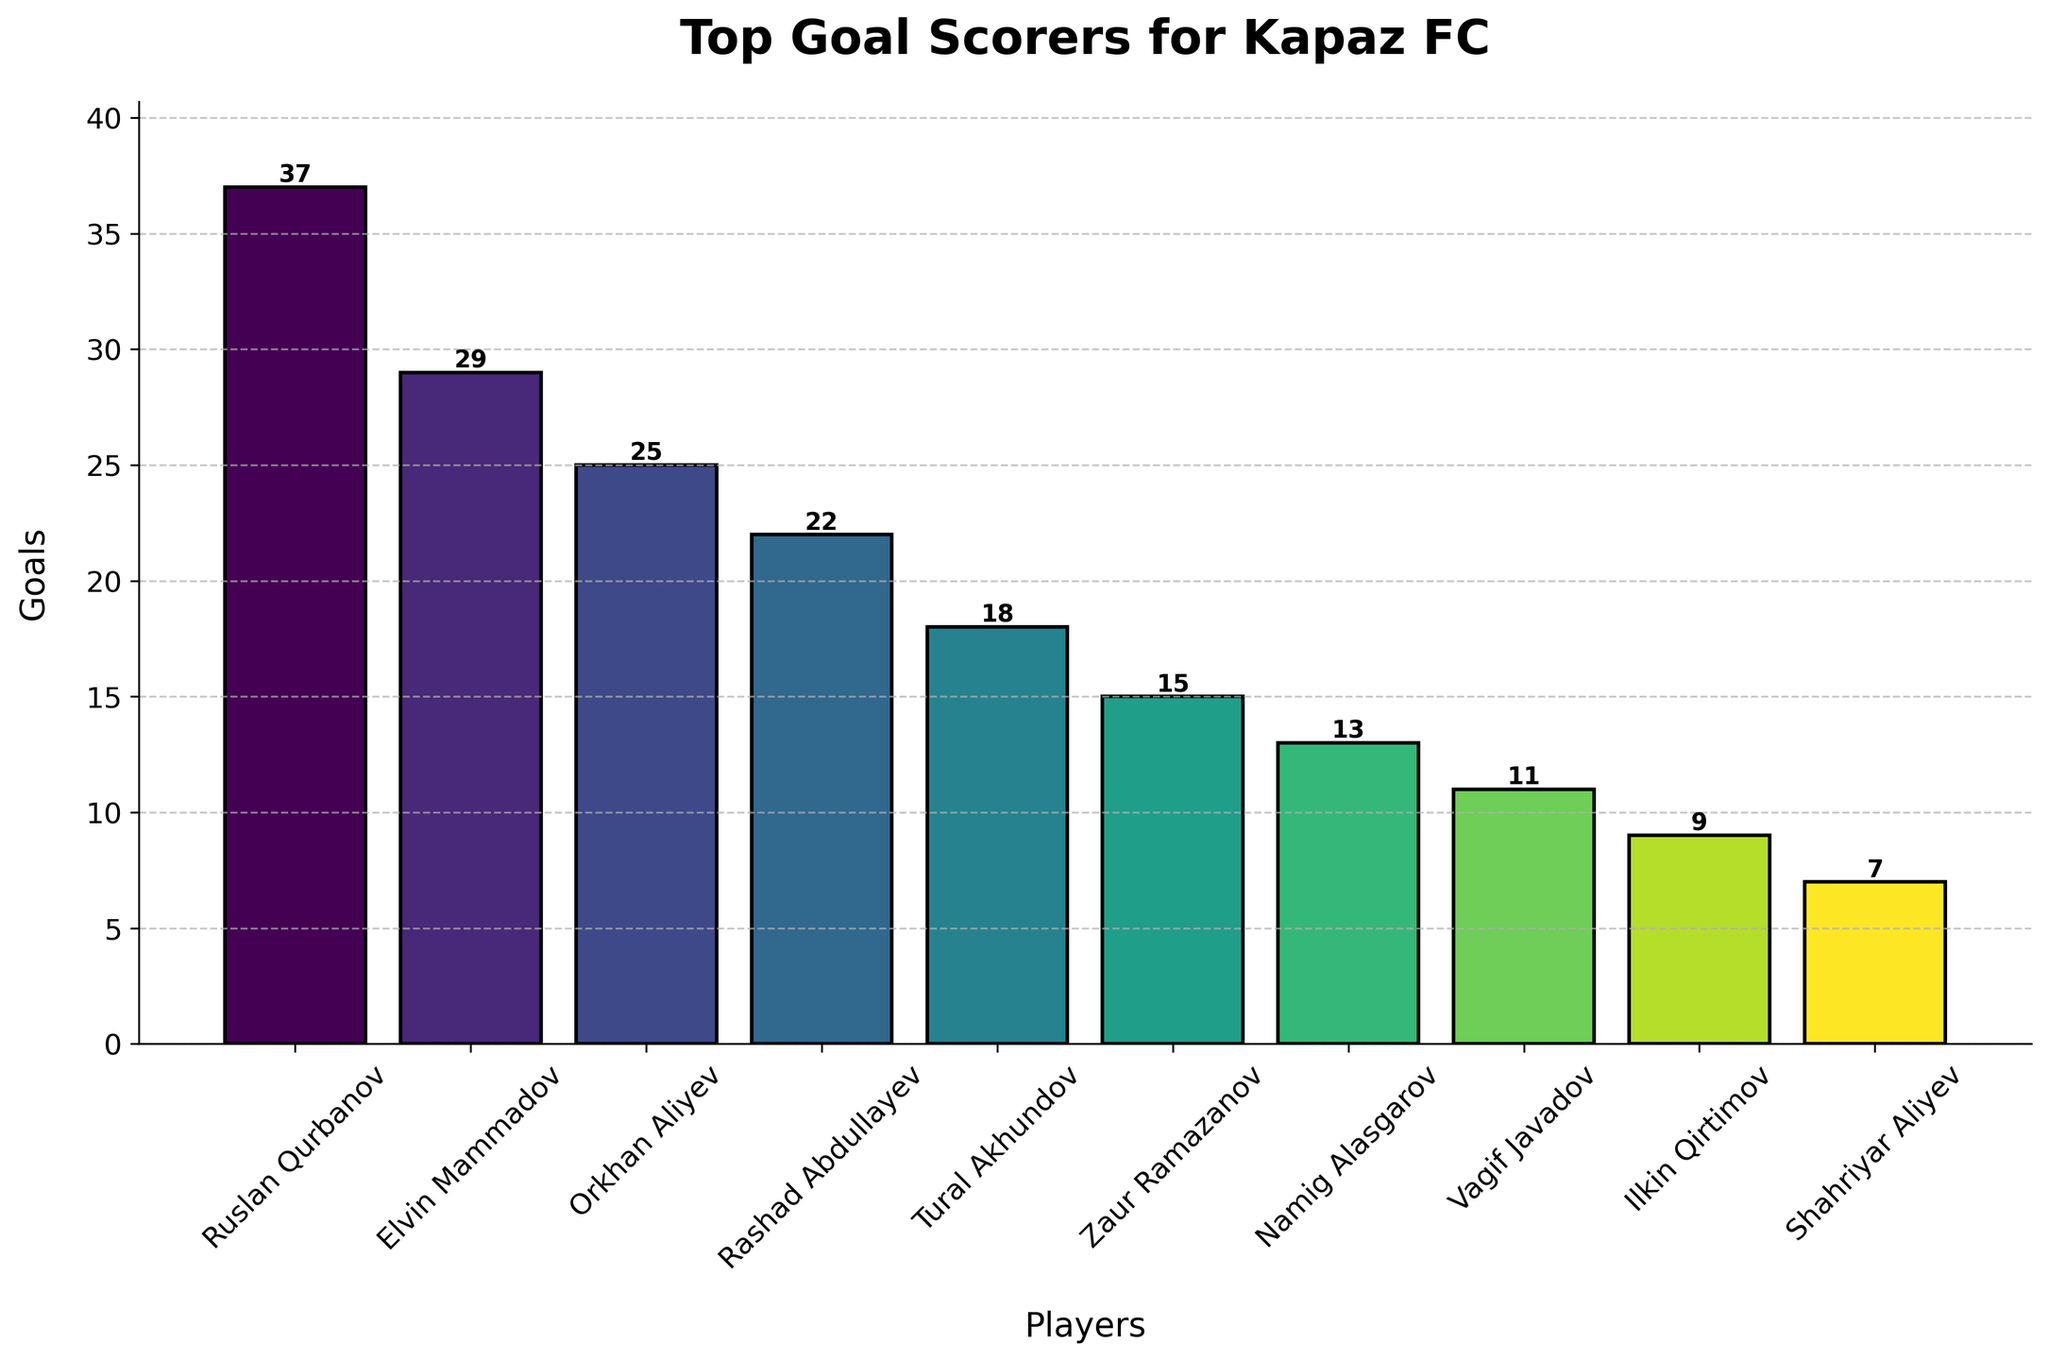What's the total number of goals scored by the top three scorers? The top three scorers are Ruslan Qurbanov (37 goals), Elvin Mammadov (29 goals), and Orkhan Aliyev (25 goals). Sum their goals: 37 + 29 + 25 = 91
Answer: 91 Who scored more goals, Tural Akhundov or Zaur Ramazanov? Tural Akhundov scored 18 goals and Zaur Ramazanov scored 15 goals. 18 is greater than 15, so Tural Akhundov scored more goals.
Answer: Tural Akhundov What's the difference in the number of goals between Rashad Abdullayev and Namig Alasgarov? Rashad Abdullayev scored 22 goals, and Namig Alasgarov scored 13 goals. The difference is 22 - 13 = 9
Answer: 9 Which player scored the least number of goals in the dataset? Shahriyar Aliyev scored 7 goals, which is the smallest number among the listed players.
Answer: Shahriyar Aliyev What's the average number of goals scored by all the players? Sum all the goals: 37 + 29 + 25 + 22 + 18 + 15 + 13 + 11 + 9 + 7 = 186. There are 10 players, so the average number of goals is 186 / 10 = 18.6
Answer: 18.6 How many players scored more than 20 goals? Ruslan Qurbanov, Elvin Mammadov, Orkhan Aliyev, and Rashad Abdullayev each scored more than 20 goals. Thus, there are 4 players.
Answer: 4 Which player has the tallest bar on the plot? Ruslan Qurbanov has the tallest bar with 37 goals.
Answer: Ruslan Qurbanov What is the combined number of goals scored by players with more than 10 but less than 20 goals? The players are Tural Akhundov (18 goals), Zaur Ramazanov (15 goals), and Namig Alasgarov (13 goals). Sum their goals: 18 + 15 + 13 = 46
Answer: 46 Are there more players who scored 10 or more goals or fewer than 10 goals? Players who scored 10 or more goals: 8 (Ruslan Qurbanov, Elvin Mammadov, Orkhan Aliyev, Rashad Abdullayev, Tural Akhundov, Zaur Ramazanov, Namig Alasgarov, Vagif Javadov). Players who scored fewer than 10 goals: 2 (Ilkin Qirtimov, Shahriyar Aliyev). 8 > 2, so more players scored 10 or more goals.
Answer: 10 or more goals Which players scored less than 15 goals but more than 10 goals? The players are Namig Alasgarov (13 goals) and Vagif Javadov (11 goals).
Answer: Namig Alasgarov and Vagif Javadov 